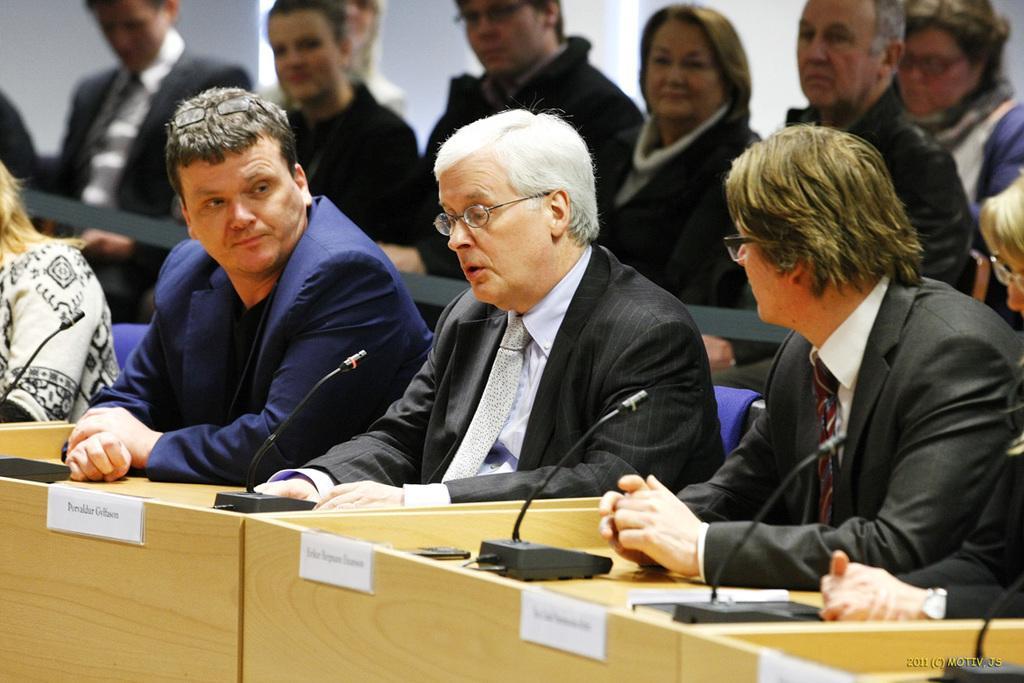Please provide a concise description of this image. This picture is clicked inside. In the foreground we can see the desks and we can see the microphones attached the stands and there are group of people sitting on the blue color chairs. In the background there is a wall. 